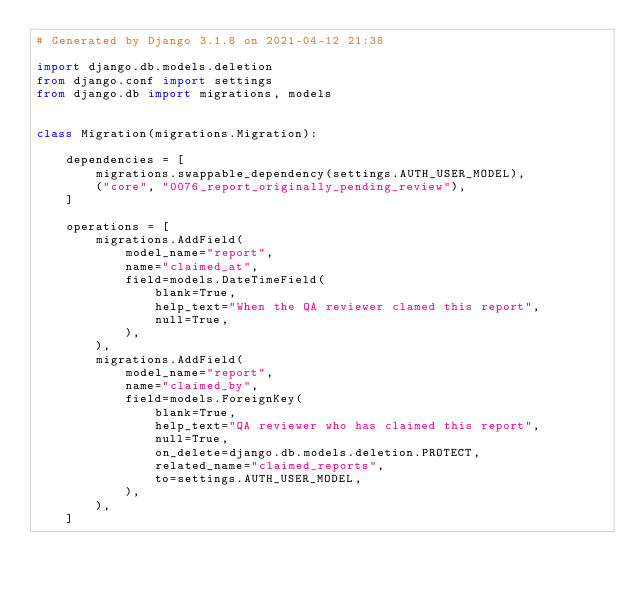Convert code to text. <code><loc_0><loc_0><loc_500><loc_500><_Python_># Generated by Django 3.1.8 on 2021-04-12 21:38

import django.db.models.deletion
from django.conf import settings
from django.db import migrations, models


class Migration(migrations.Migration):

    dependencies = [
        migrations.swappable_dependency(settings.AUTH_USER_MODEL),
        ("core", "0076_report_originally_pending_review"),
    ]

    operations = [
        migrations.AddField(
            model_name="report",
            name="claimed_at",
            field=models.DateTimeField(
                blank=True,
                help_text="When the QA reviewer clamed this report",
                null=True,
            ),
        ),
        migrations.AddField(
            model_name="report",
            name="claimed_by",
            field=models.ForeignKey(
                blank=True,
                help_text="QA reviewer who has claimed this report",
                null=True,
                on_delete=django.db.models.deletion.PROTECT,
                related_name="claimed_reports",
                to=settings.AUTH_USER_MODEL,
            ),
        ),
    ]
</code> 